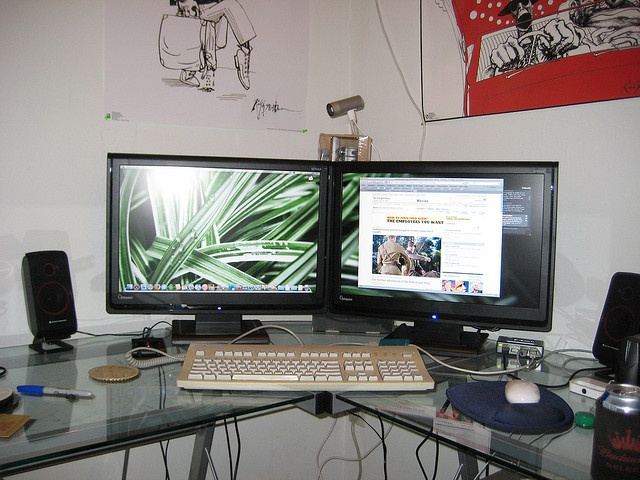Describe the objects in this image and their specific colors. I can see tv in gray, black, white, and darkgray tones, tv in gray, black, white, and darkgray tones, keyboard in gray, darkgray, and lightgray tones, and mouse in gray, darkgray, and lightgray tones in this image. 